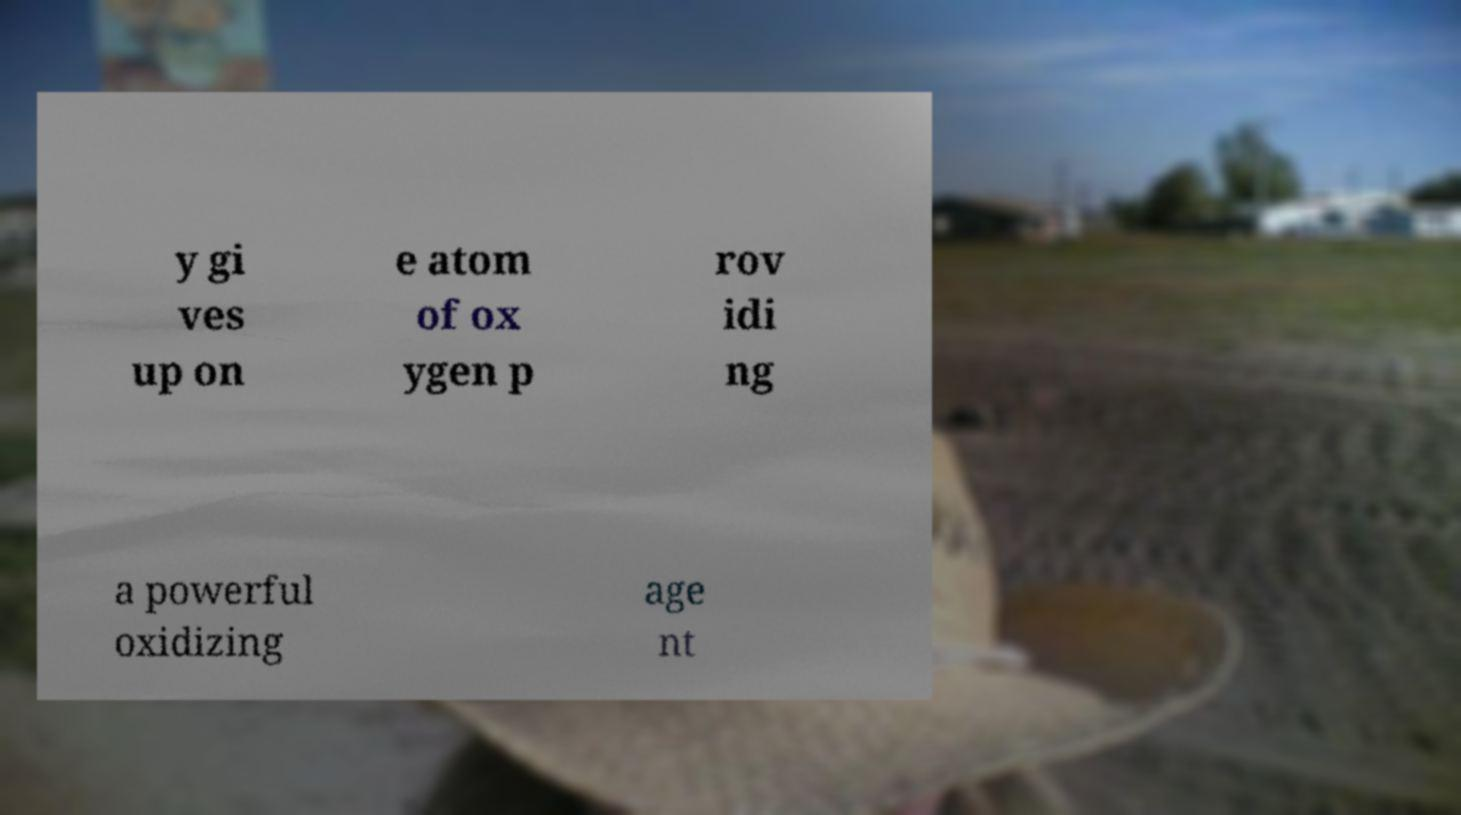Please identify and transcribe the text found in this image. y gi ves up on e atom of ox ygen p rov idi ng a powerful oxidizing age nt 